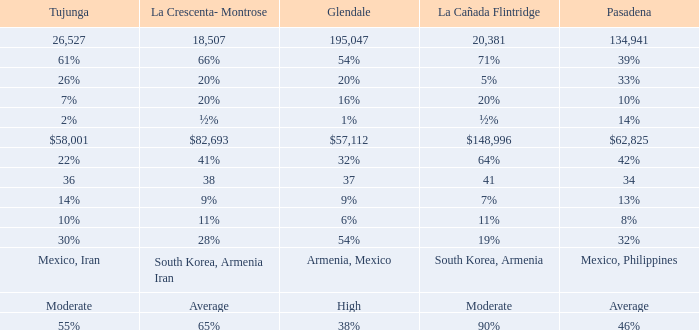What is the la crescenta-montrose value when glendale's figure is $57,112? $82,693. 